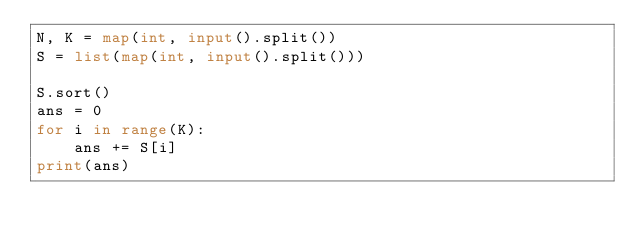<code> <loc_0><loc_0><loc_500><loc_500><_Python_>N, K = map(int, input().split())
S = list(map(int, input().split()))

S.sort()
ans = 0
for i in range(K):
    ans += S[i]
print(ans)</code> 